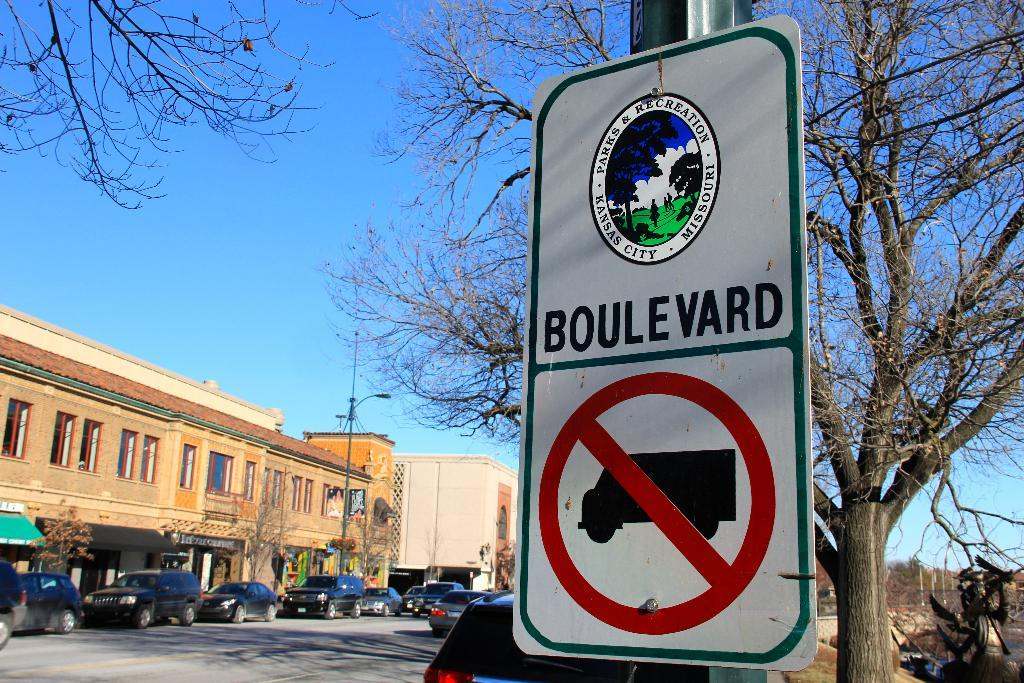<image>
Render a clear and concise summary of the photo. Road sign that says Boulevard and no trucks. 